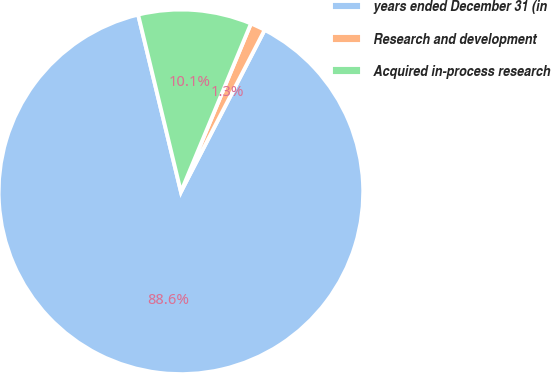Convert chart to OTSL. <chart><loc_0><loc_0><loc_500><loc_500><pie_chart><fcel>years ended December 31 (in<fcel>Research and development<fcel>Acquired in-process research<nl><fcel>88.63%<fcel>1.32%<fcel>10.05%<nl></chart> 